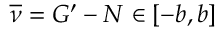Convert formula to latex. <formula><loc_0><loc_0><loc_500><loc_500>\overline { \nu } = G ^ { \prime } - N \in [ - b , b ]</formula> 